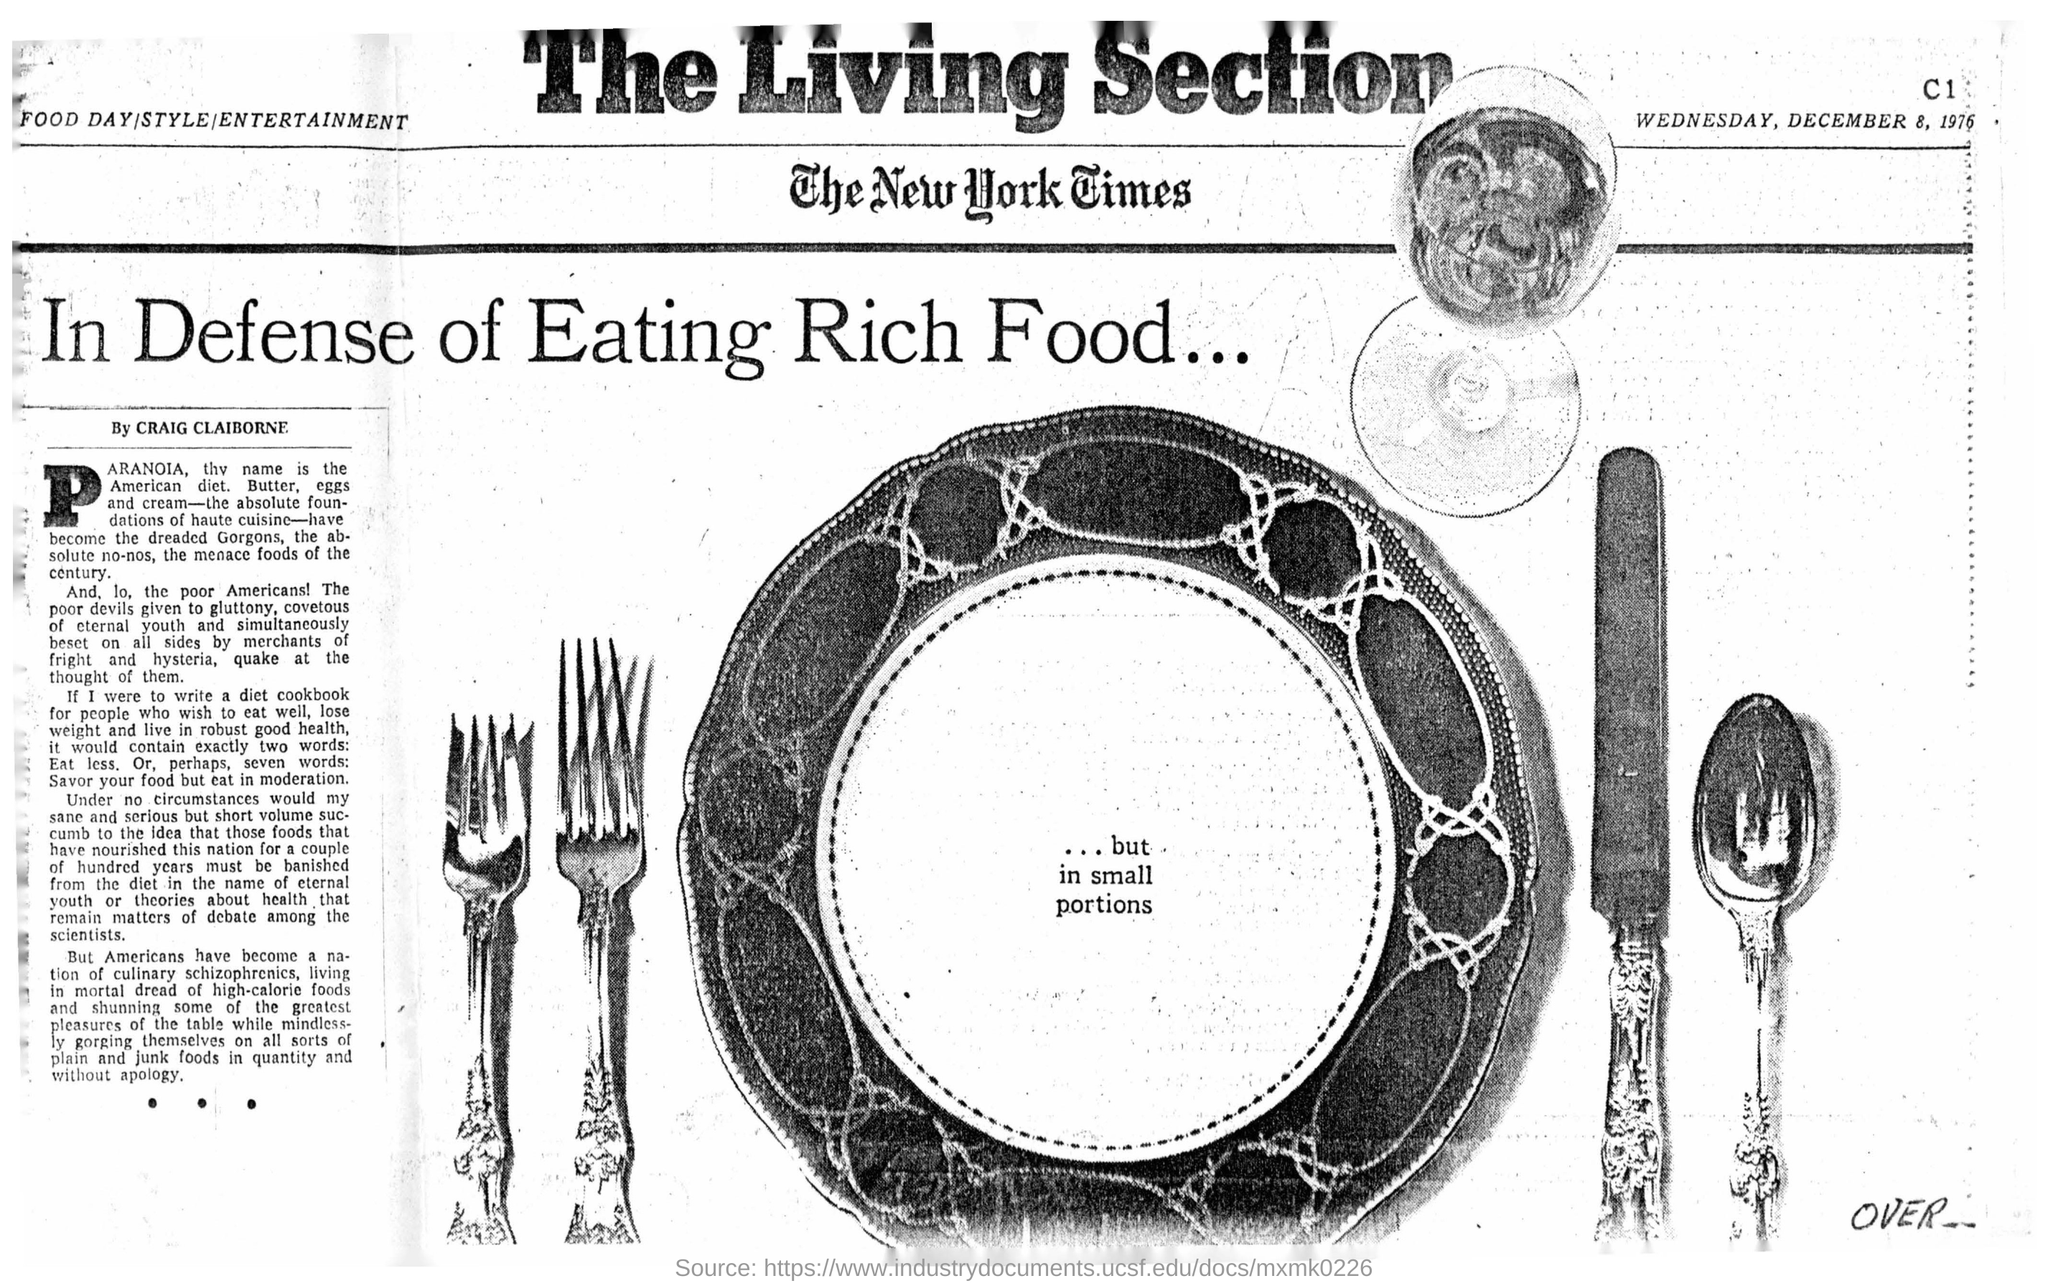Give some essential details in this illustration. The date mentioned in the newspaper is Wednesday, December 8, 1976. The name of the newspaper is The New York Times. Craig Claiborne is the news writer. The headline of this news is "In Defense of Eating Rich Foods. 